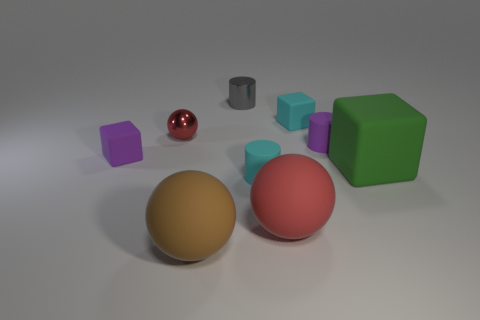What number of big spheres have the same color as the small sphere? There is one large sphere that shares the same glossy red color as the small sphere. 